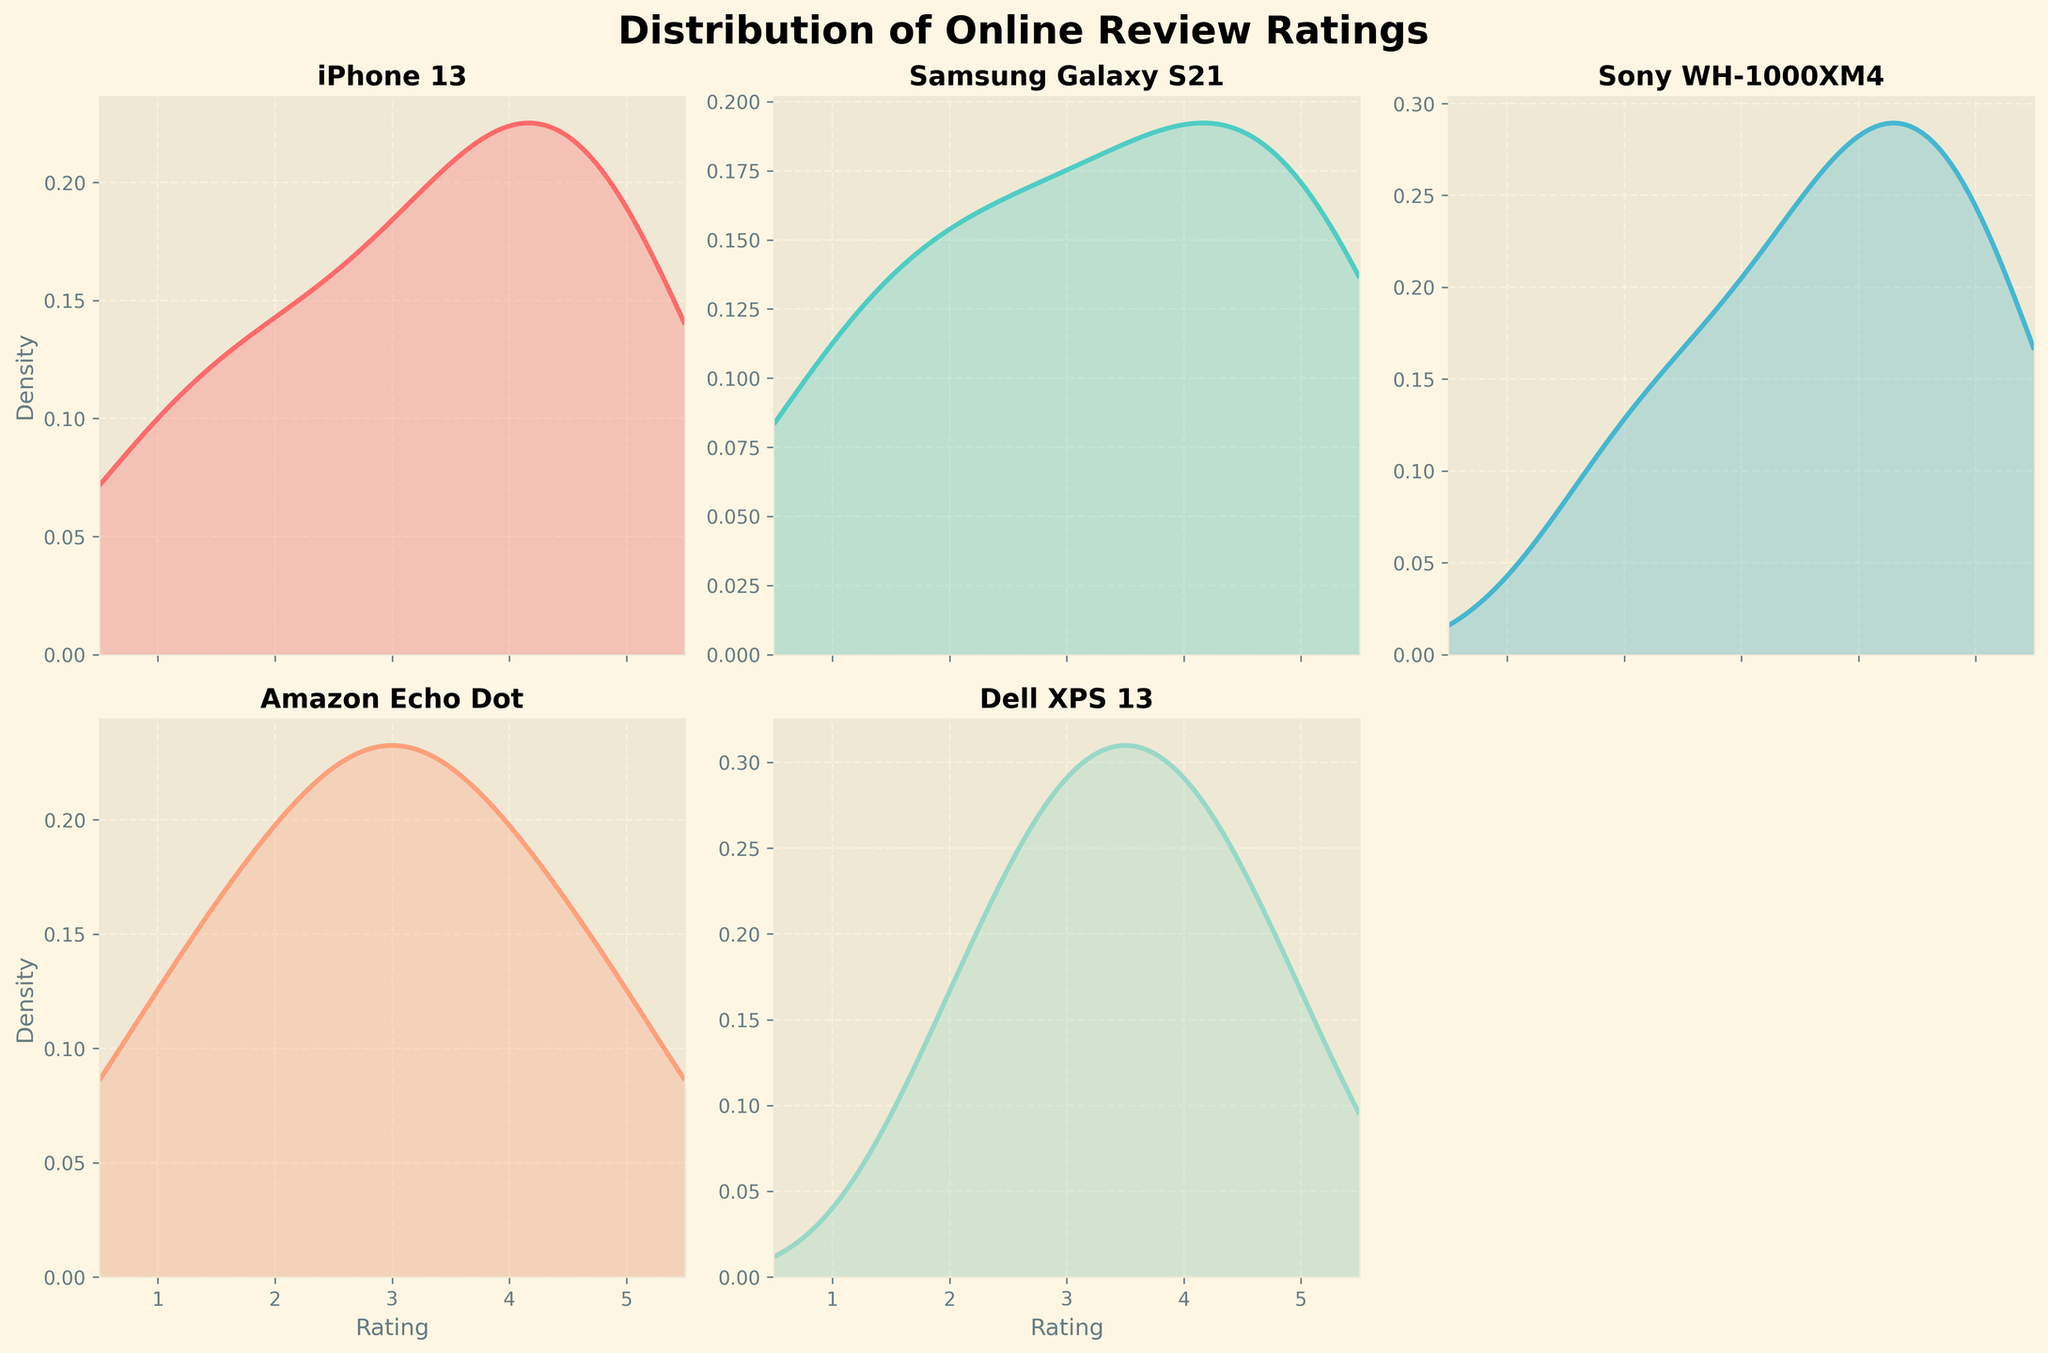Which product shows the highest rating density peak? By looking at the peaks of the density lines, identify which product has the highest peak point among all the subplots. This is the product with the highest density for a specific rating.
Answer: Samsung Galaxy S21 Which product has the most variation in its review ratings? By inspecting the width of the density plots, determine which product's ratings are spread out the most. A wider density plot indicates more variation in ratings.
Answer: iPhone 13 Which product has the most reviews clustered around the middle rating (3)? Analyze the density plots to see which product has a higher peak around the rating of 3. The product with the tallest peak close to 3 has the most reviews clustered around this rating.
Answer: Amazon Echo Dot How does the distribution for 'Dell XPS 13' compare to that of 'Sony WH-1000XM4'? Compare the density plots of both products. Consider the spread and peak of the distributions. Dell XPS 13 has a peak around 3 and 4 but 'Sony WH-1000XM4' has significant peaks around ratings 4 and 5.
Answer: Dell XPS 13 is more balanced, while Sony WH-1000XM4 peaks higher at 4 and 5 Which product has the highest density at a rating of 5? Check which plot has the tallest density value at the rating of 5. The product with the highest peak at 5 is the answer.
Answer: Samsung Galaxy S21 What is the general trend in the review ratings for the 'iPhone 13'? Observe the shape of the iPhone 13 plot. Identify whether the density increases or decreases as the rating goes higher.
Answer: The density increases steadily, indicating improving satisfaction with higher ratings Are there any products with noticeable negative reviews around rating 1? Which ones? Look for significant density peaks around the rating of 1 in the plots. Products with higher density near 1 indicate more negative reviews.
Answer: iPhone 13 and Samsung Galaxy S21 Among all the products, which one has a relatively balanced distribution of ratings? Identify the plot where the density is relatively even across ratings 1 to 5. A balanced distribution will not have extremely high peaks or low troughs.
Answer: Dell XPS 13 